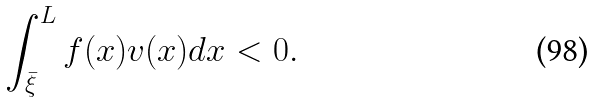Convert formula to latex. <formula><loc_0><loc_0><loc_500><loc_500>\int _ { \bar { \xi } } ^ { L } f ( x ) v ( x ) d x < 0 .</formula> 